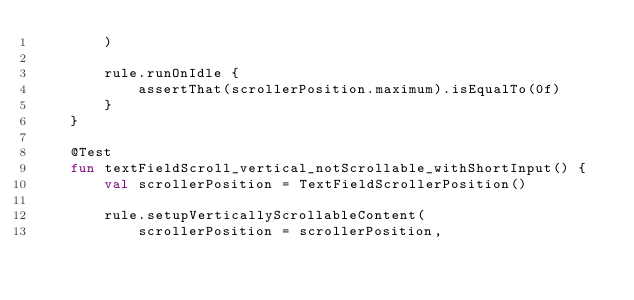Convert code to text. <code><loc_0><loc_0><loc_500><loc_500><_Kotlin_>        )

        rule.runOnIdle {
            assertThat(scrollerPosition.maximum).isEqualTo(0f)
        }
    }

    @Test
    fun textFieldScroll_vertical_notScrollable_withShortInput() {
        val scrollerPosition = TextFieldScrollerPosition()

        rule.setupVerticallyScrollableContent(
            scrollerPosition = scrollerPosition,</code> 